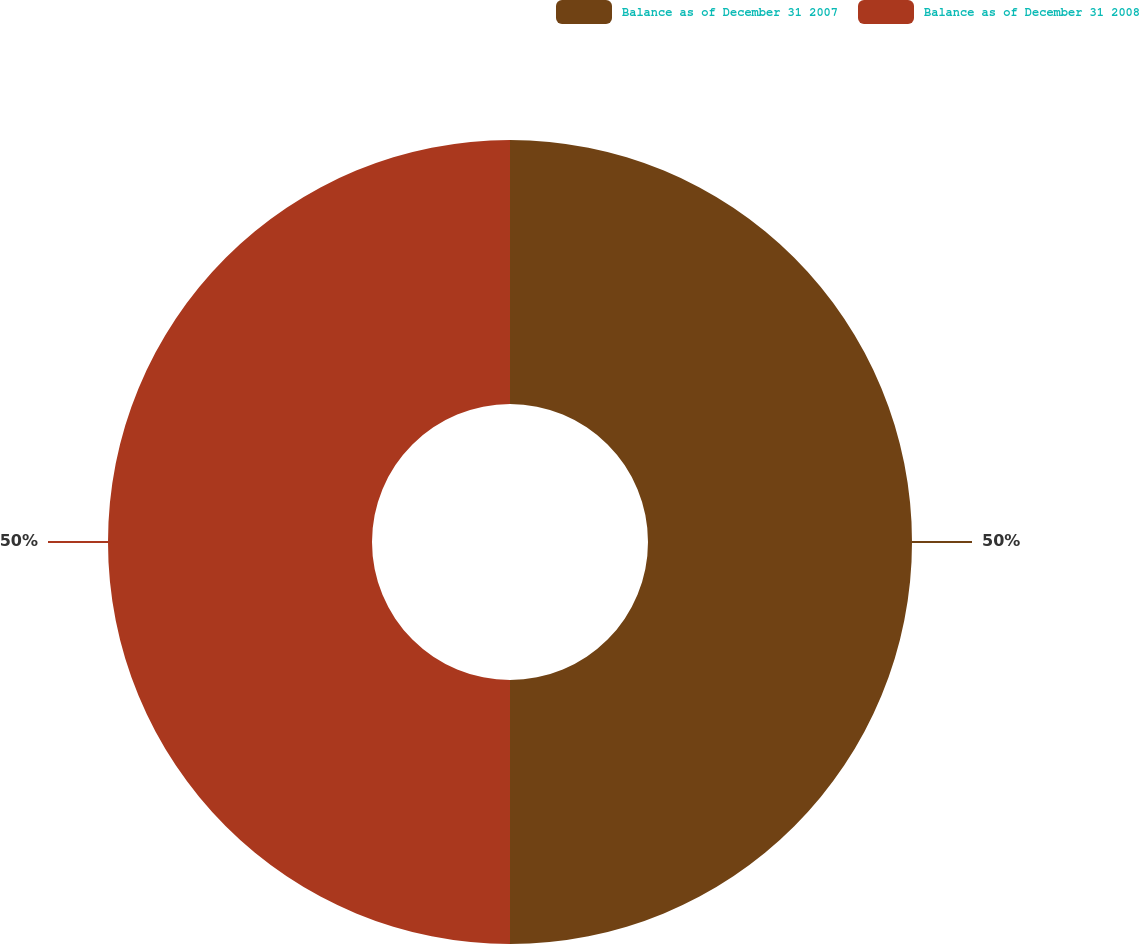Convert chart. <chart><loc_0><loc_0><loc_500><loc_500><pie_chart><fcel>Balance as of December 31 2007<fcel>Balance as of December 31 2008<nl><fcel>50.0%<fcel>50.0%<nl></chart> 